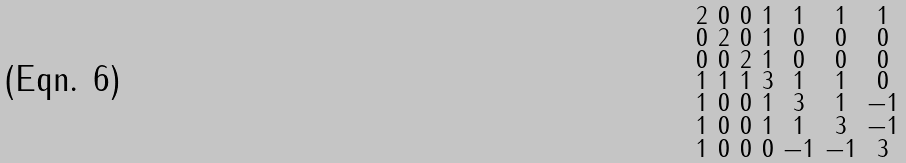<formula> <loc_0><loc_0><loc_500><loc_500>\begin{smallmatrix} 2 & 0 & 0 & 1 & 1 & 1 & 1 \\ 0 & 2 & 0 & 1 & 0 & 0 & 0 \\ 0 & 0 & 2 & 1 & 0 & 0 & 0 \\ 1 & 1 & 1 & 3 & 1 & 1 & 0 \\ 1 & 0 & 0 & 1 & 3 & 1 & - 1 \\ 1 & 0 & 0 & 1 & 1 & 3 & - 1 \\ 1 & 0 & 0 & 0 & - 1 & - 1 & 3 \end{smallmatrix}</formula> 